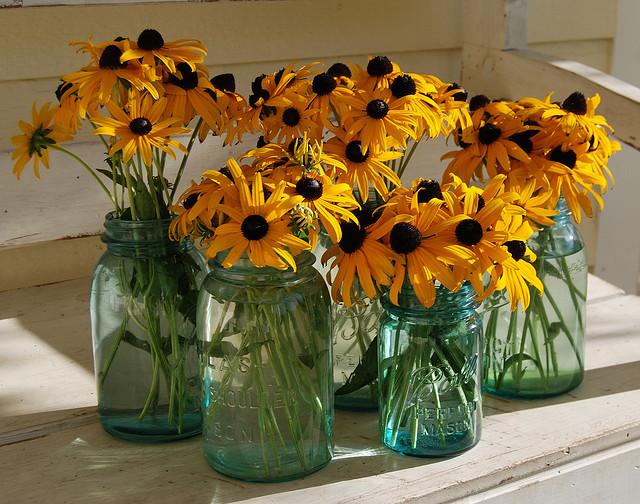How many jars are there?
Write a very short answer. 5. What are these flowers called?
Keep it brief. Daisies. How many vases are on the table?
Quick response, please. 5. Are these flowers in the sun?
Answer briefly. Yes. How many vases in the picture?
Short answer required. 5. 